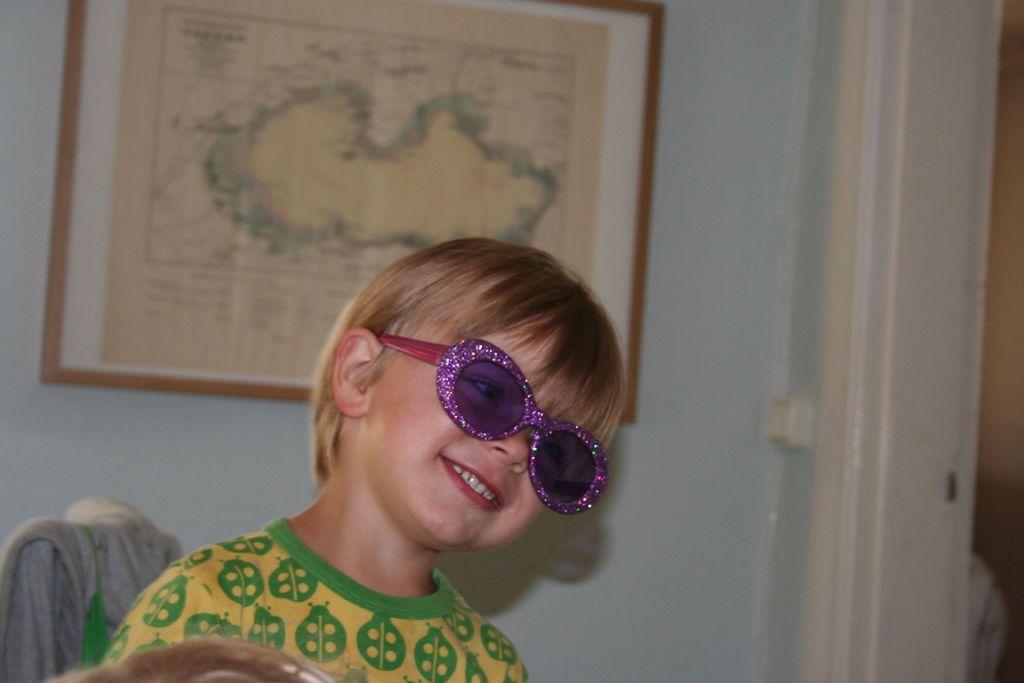Could you give a brief overview of what you see in this image? In the picture we can see a child sitting on a chair and smiling and wearing a glass to the eyes and in the background, we can see a wall with a photo frame and a map on it. 